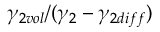<formula> <loc_0><loc_0><loc_500><loc_500>\gamma _ { 2 v o l } / ( \gamma _ { 2 } - \gamma _ { 2 d i f f } )</formula> 